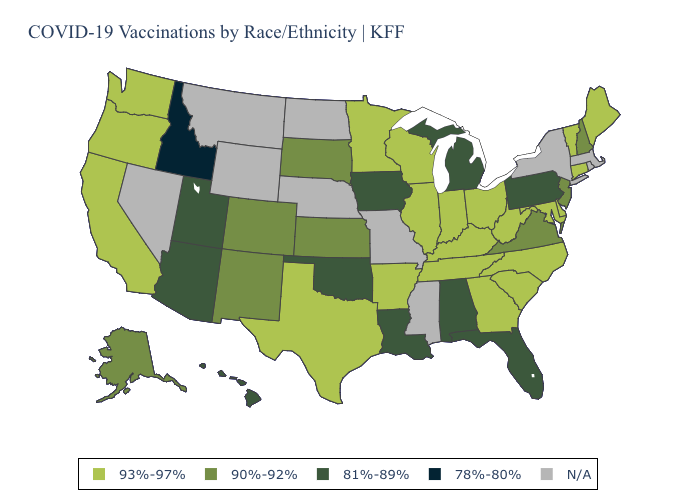What is the value of Kansas?
Quick response, please. 90%-92%. Name the states that have a value in the range 93%-97%?
Short answer required. Arkansas, California, Connecticut, Delaware, Georgia, Illinois, Indiana, Kentucky, Maine, Maryland, Minnesota, North Carolina, Ohio, Oregon, South Carolina, Tennessee, Texas, Vermont, Washington, West Virginia, Wisconsin. Name the states that have a value in the range 81%-89%?
Short answer required. Alabama, Arizona, Florida, Hawaii, Iowa, Louisiana, Michigan, Oklahoma, Pennsylvania, Utah. What is the lowest value in states that border Wisconsin?
Quick response, please. 81%-89%. Is the legend a continuous bar?
Give a very brief answer. No. Name the states that have a value in the range 90%-92%?
Answer briefly. Alaska, Colorado, Kansas, New Hampshire, New Jersey, New Mexico, South Dakota, Virginia. Which states have the lowest value in the MidWest?
Short answer required. Iowa, Michigan. What is the value of Massachusetts?
Short answer required. N/A. What is the lowest value in the USA?
Be succinct. 78%-80%. Does Idaho have the lowest value in the USA?
Quick response, please. Yes. Name the states that have a value in the range 93%-97%?
Concise answer only. Arkansas, California, Connecticut, Delaware, Georgia, Illinois, Indiana, Kentucky, Maine, Maryland, Minnesota, North Carolina, Ohio, Oregon, South Carolina, Tennessee, Texas, Vermont, Washington, West Virginia, Wisconsin. What is the value of Louisiana?
Short answer required. 81%-89%. What is the value of Minnesota?
Answer briefly. 93%-97%. Name the states that have a value in the range 93%-97%?
Answer briefly. Arkansas, California, Connecticut, Delaware, Georgia, Illinois, Indiana, Kentucky, Maine, Maryland, Minnesota, North Carolina, Ohio, Oregon, South Carolina, Tennessee, Texas, Vermont, Washington, West Virginia, Wisconsin. 